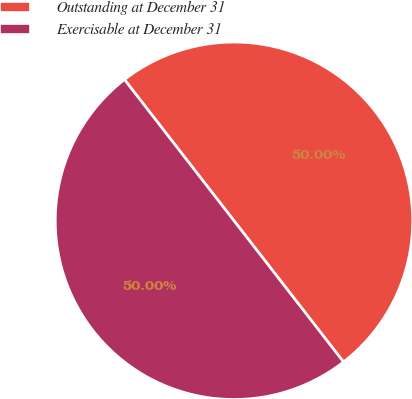Convert chart to OTSL. <chart><loc_0><loc_0><loc_500><loc_500><pie_chart><fcel>Outstanding at December 31<fcel>Exercisable at December 31<nl><fcel>50.0%<fcel>50.0%<nl></chart> 